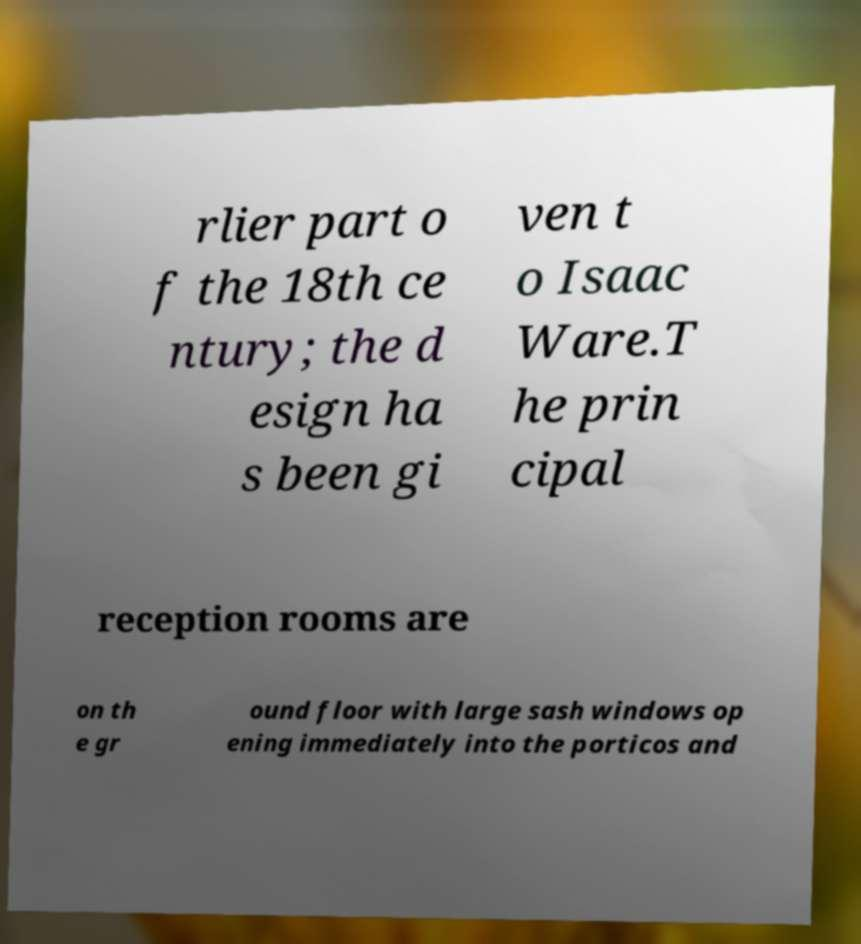Can you read and provide the text displayed in the image?This photo seems to have some interesting text. Can you extract and type it out for me? rlier part o f the 18th ce ntury; the d esign ha s been gi ven t o Isaac Ware.T he prin cipal reception rooms are on th e gr ound floor with large sash windows op ening immediately into the porticos and 